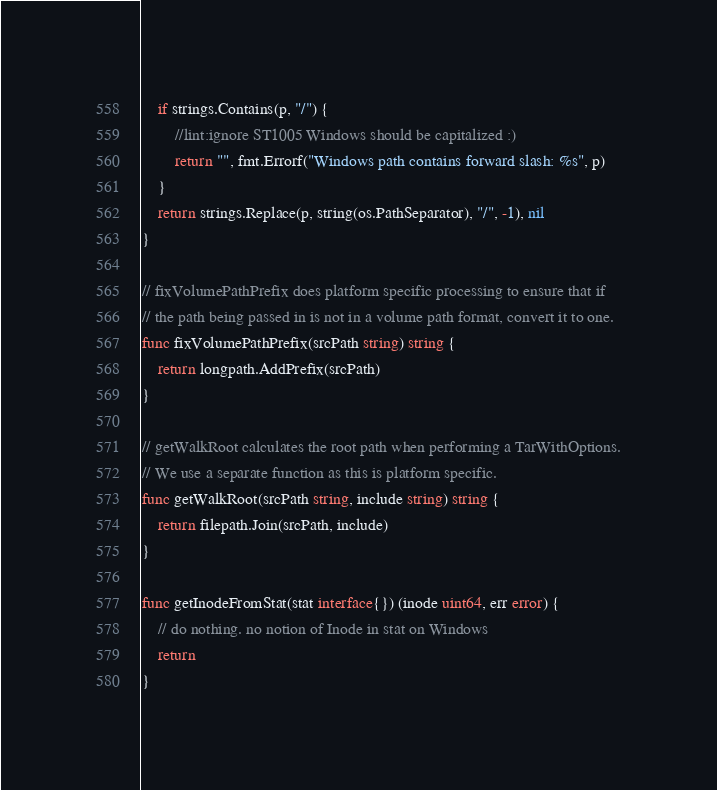Convert code to text. <code><loc_0><loc_0><loc_500><loc_500><_Go_>	if strings.Contains(p, "/") {
		//lint:ignore ST1005 Windows should be capitalized :)
		return "", fmt.Errorf("Windows path contains forward slash: %s", p)
	}
	return strings.Replace(p, string(os.PathSeparator), "/", -1), nil
}

// fixVolumePathPrefix does platform specific processing to ensure that if
// the path being passed in is not in a volume path format, convert it to one.
func fixVolumePathPrefix(srcPath string) string {
	return longpath.AddPrefix(srcPath)
}

// getWalkRoot calculates the root path when performing a TarWithOptions.
// We use a separate function as this is platform specific.
func getWalkRoot(srcPath string, include string) string {
	return filepath.Join(srcPath, include)
}

func getInodeFromStat(stat interface{}) (inode uint64, err error) {
	// do nothing. no notion of Inode in stat on Windows
	return
}
</code> 